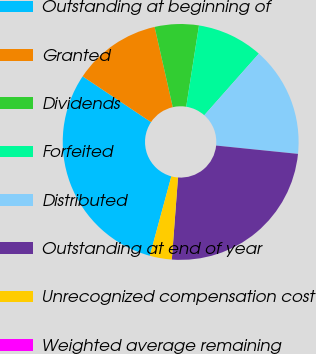<chart> <loc_0><loc_0><loc_500><loc_500><pie_chart><fcel>Outstanding at beginning of<fcel>Granted<fcel>Dividends<fcel>Forfeited<fcel>Distributed<fcel>Outstanding at end of year<fcel>Unrecognized compensation cost<fcel>Weighted average remaining<nl><fcel>30.17%<fcel>12.07%<fcel>6.03%<fcel>9.05%<fcel>15.08%<fcel>24.58%<fcel>3.02%<fcel>0.0%<nl></chart> 